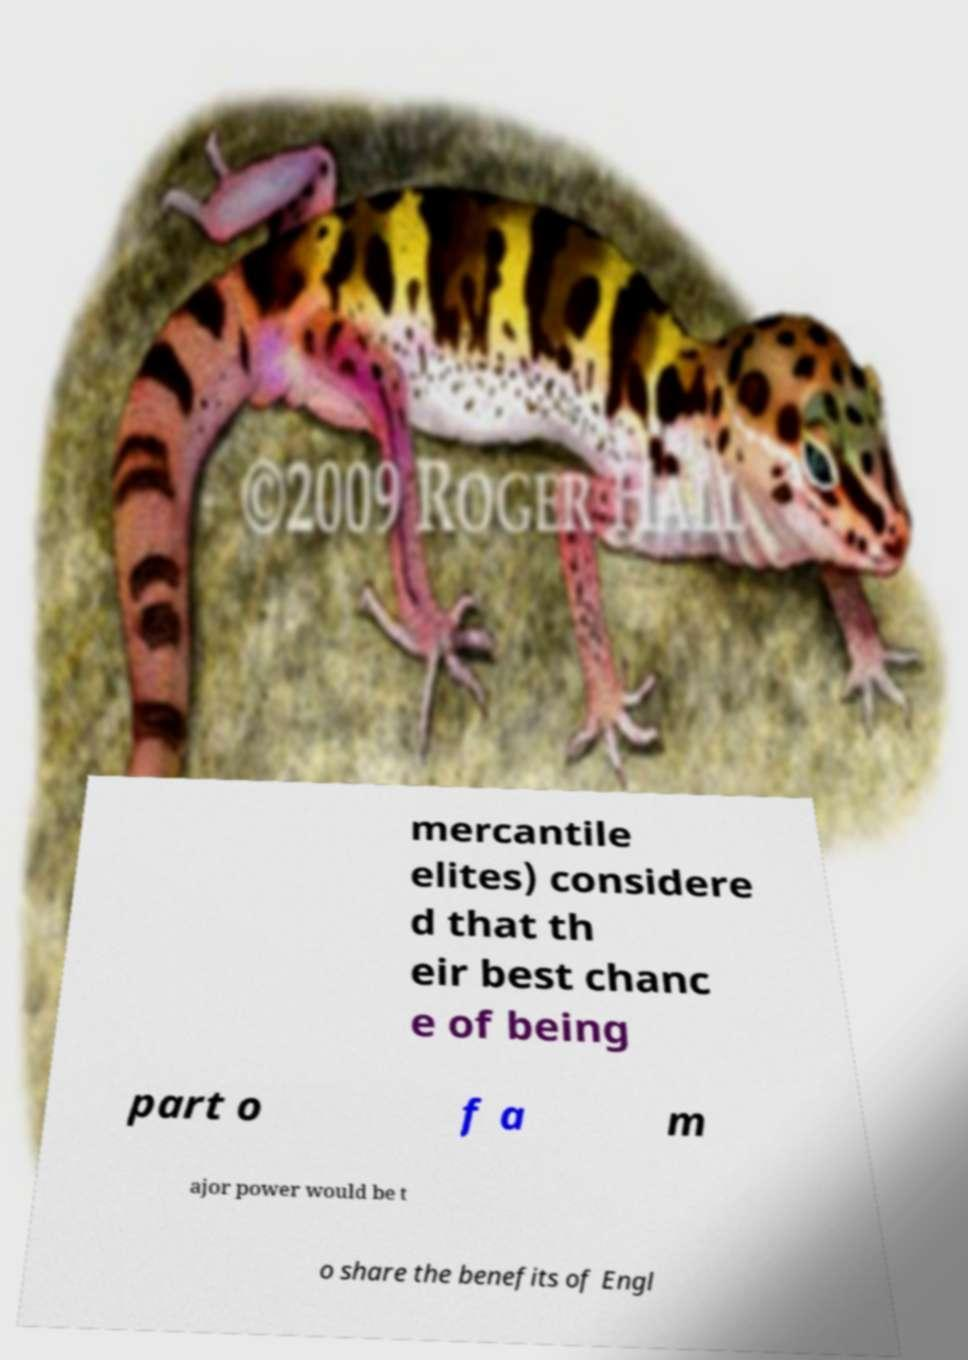Please identify and transcribe the text found in this image. mercantile elites) considere d that th eir best chanc e of being part o f a m ajor power would be t o share the benefits of Engl 